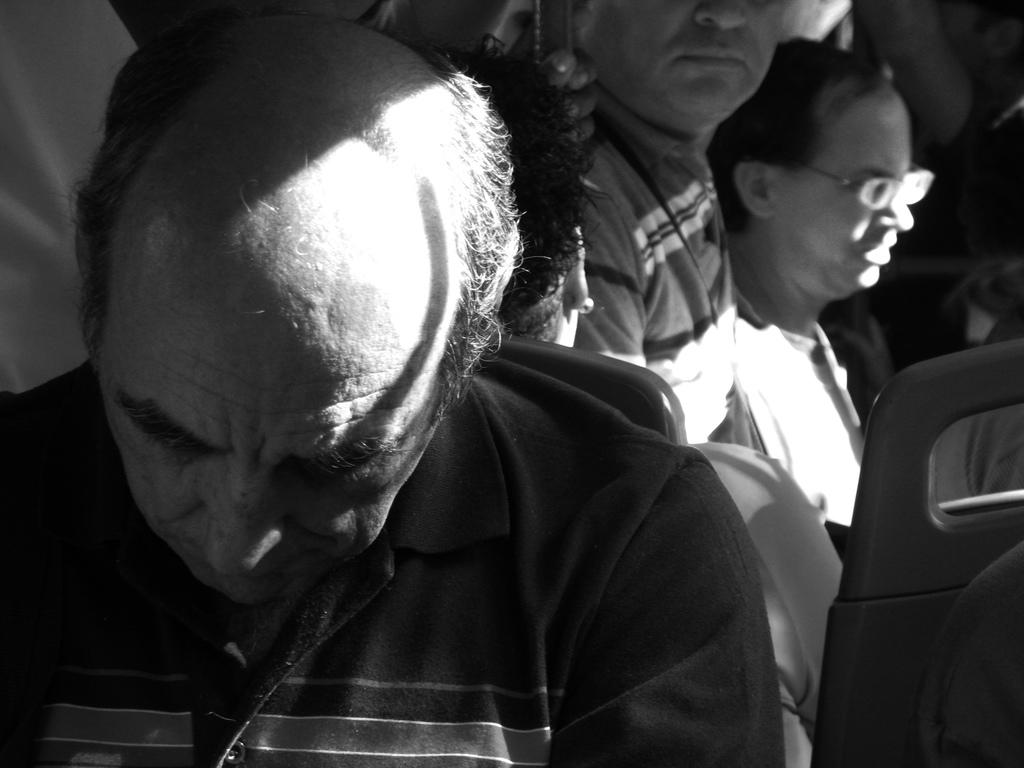What is the setting of the image? The image is taken in a crowded bus. What can be seen in the foreground of the image? There are seats in the foreground, and a person is sleeping in the foreground. What type of bomb can be seen in the image? There is no bomb present in the image. How is the paste being used in the image? There is no paste present in the image. 